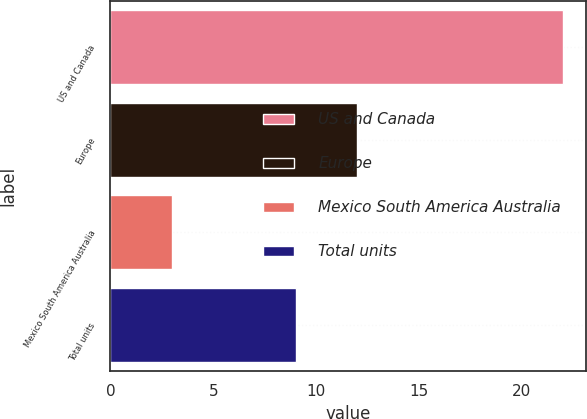<chart> <loc_0><loc_0><loc_500><loc_500><bar_chart><fcel>US and Canada<fcel>Europe<fcel>Mexico South America Australia<fcel>Total units<nl><fcel>22<fcel>12<fcel>3<fcel>9<nl></chart> 